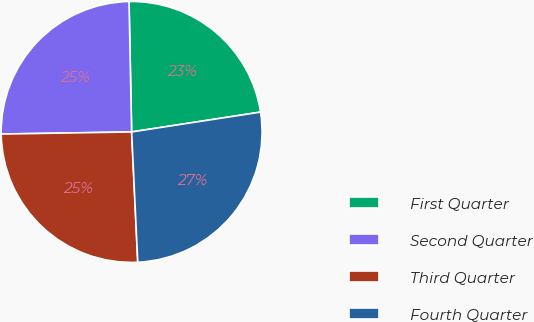Convert chart. <chart><loc_0><loc_0><loc_500><loc_500><pie_chart><fcel>First Quarter<fcel>Second Quarter<fcel>Third Quarter<fcel>Fourth Quarter<nl><fcel>22.89%<fcel>24.94%<fcel>25.49%<fcel>26.68%<nl></chart> 